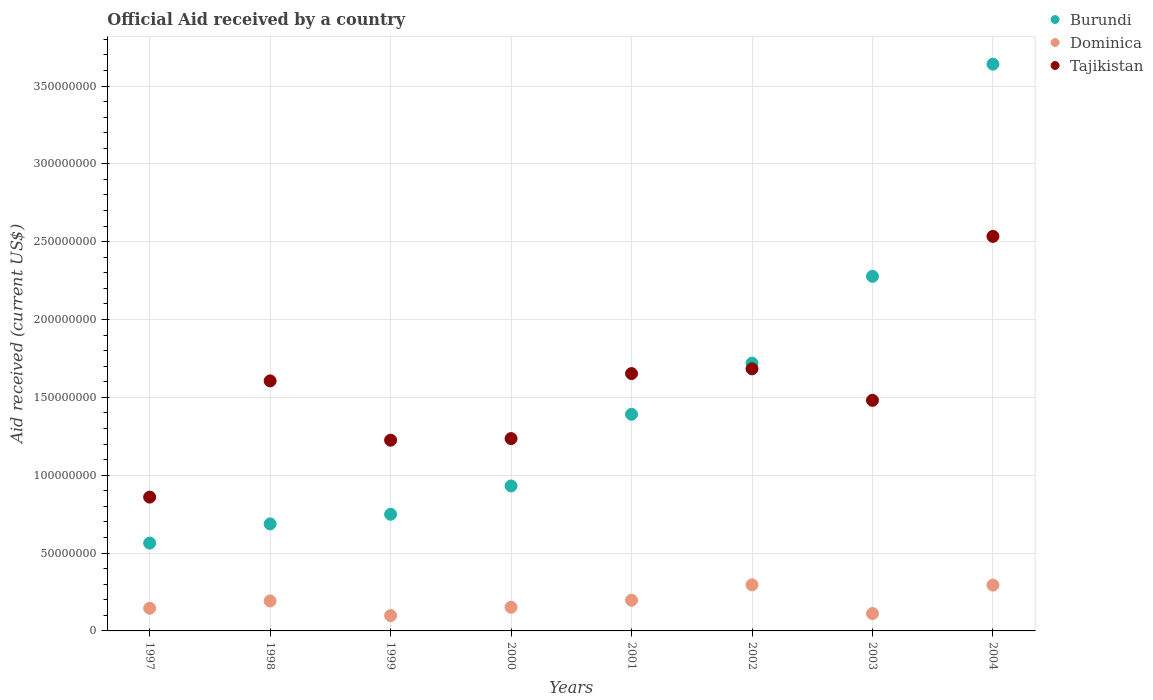What is the net official aid received in Tajikistan in 1999?
Give a very brief answer. 1.22e+08. Across all years, what is the maximum net official aid received in Burundi?
Ensure brevity in your answer.  3.64e+08. Across all years, what is the minimum net official aid received in Dominica?
Make the answer very short. 9.84e+06. In which year was the net official aid received in Tajikistan maximum?
Ensure brevity in your answer.  2004. What is the total net official aid received in Tajikistan in the graph?
Keep it short and to the point. 1.23e+09. What is the difference between the net official aid received in Burundi in 1997 and that in 1999?
Ensure brevity in your answer.  -1.85e+07. What is the difference between the net official aid received in Burundi in 2003 and the net official aid received in Tajikistan in 2000?
Provide a succinct answer. 1.04e+08. What is the average net official aid received in Dominica per year?
Keep it short and to the point. 1.86e+07. In the year 1999, what is the difference between the net official aid received in Burundi and net official aid received in Dominica?
Offer a very short reply. 6.51e+07. What is the ratio of the net official aid received in Tajikistan in 2000 to that in 2004?
Ensure brevity in your answer.  0.49. Is the net official aid received in Dominica in 2000 less than that in 2001?
Ensure brevity in your answer.  Yes. Is the difference between the net official aid received in Burundi in 1998 and 2004 greater than the difference between the net official aid received in Dominica in 1998 and 2004?
Keep it short and to the point. No. What is the difference between the highest and the second highest net official aid received in Burundi?
Offer a very short reply. 1.36e+08. What is the difference between the highest and the lowest net official aid received in Tajikistan?
Keep it short and to the point. 1.67e+08. In how many years, is the net official aid received in Tajikistan greater than the average net official aid received in Tajikistan taken over all years?
Keep it short and to the point. 4. Is it the case that in every year, the sum of the net official aid received in Dominica and net official aid received in Tajikistan  is greater than the net official aid received in Burundi?
Ensure brevity in your answer.  No. Does the net official aid received in Tajikistan monotonically increase over the years?
Provide a succinct answer. No. Is the net official aid received in Burundi strictly greater than the net official aid received in Dominica over the years?
Give a very brief answer. Yes. Does the graph contain grids?
Your response must be concise. Yes. How are the legend labels stacked?
Your answer should be very brief. Vertical. What is the title of the graph?
Offer a terse response. Official Aid received by a country. What is the label or title of the X-axis?
Your answer should be compact. Years. What is the label or title of the Y-axis?
Keep it short and to the point. Aid received (current US$). What is the Aid received (current US$) in Burundi in 1997?
Offer a terse response. 5.64e+07. What is the Aid received (current US$) of Dominica in 1997?
Ensure brevity in your answer.  1.46e+07. What is the Aid received (current US$) of Tajikistan in 1997?
Provide a succinct answer. 8.59e+07. What is the Aid received (current US$) in Burundi in 1998?
Your response must be concise. 6.88e+07. What is the Aid received (current US$) in Dominica in 1998?
Ensure brevity in your answer.  1.93e+07. What is the Aid received (current US$) in Tajikistan in 1998?
Your response must be concise. 1.61e+08. What is the Aid received (current US$) of Burundi in 1999?
Your answer should be very brief. 7.49e+07. What is the Aid received (current US$) in Dominica in 1999?
Ensure brevity in your answer.  9.84e+06. What is the Aid received (current US$) of Tajikistan in 1999?
Your answer should be very brief. 1.22e+08. What is the Aid received (current US$) of Burundi in 2000?
Offer a terse response. 9.31e+07. What is the Aid received (current US$) in Dominica in 2000?
Give a very brief answer. 1.52e+07. What is the Aid received (current US$) of Tajikistan in 2000?
Offer a terse response. 1.24e+08. What is the Aid received (current US$) in Burundi in 2001?
Your answer should be very brief. 1.39e+08. What is the Aid received (current US$) of Dominica in 2001?
Provide a succinct answer. 1.97e+07. What is the Aid received (current US$) in Tajikistan in 2001?
Provide a succinct answer. 1.65e+08. What is the Aid received (current US$) in Burundi in 2002?
Keep it short and to the point. 1.72e+08. What is the Aid received (current US$) in Dominica in 2002?
Your answer should be very brief. 2.96e+07. What is the Aid received (current US$) of Tajikistan in 2002?
Offer a terse response. 1.68e+08. What is the Aid received (current US$) in Burundi in 2003?
Your response must be concise. 2.28e+08. What is the Aid received (current US$) in Dominica in 2003?
Give a very brief answer. 1.12e+07. What is the Aid received (current US$) in Tajikistan in 2003?
Offer a very short reply. 1.48e+08. What is the Aid received (current US$) in Burundi in 2004?
Your answer should be very brief. 3.64e+08. What is the Aid received (current US$) of Dominica in 2004?
Ensure brevity in your answer.  2.94e+07. What is the Aid received (current US$) in Tajikistan in 2004?
Provide a succinct answer. 2.53e+08. Across all years, what is the maximum Aid received (current US$) in Burundi?
Keep it short and to the point. 3.64e+08. Across all years, what is the maximum Aid received (current US$) in Dominica?
Keep it short and to the point. 2.96e+07. Across all years, what is the maximum Aid received (current US$) of Tajikistan?
Provide a succinct answer. 2.53e+08. Across all years, what is the minimum Aid received (current US$) of Burundi?
Offer a very short reply. 5.64e+07. Across all years, what is the minimum Aid received (current US$) in Dominica?
Give a very brief answer. 9.84e+06. Across all years, what is the minimum Aid received (current US$) in Tajikistan?
Offer a terse response. 8.59e+07. What is the total Aid received (current US$) of Burundi in the graph?
Provide a succinct answer. 1.20e+09. What is the total Aid received (current US$) in Dominica in the graph?
Offer a terse response. 1.49e+08. What is the total Aid received (current US$) of Tajikistan in the graph?
Provide a succinct answer. 1.23e+09. What is the difference between the Aid received (current US$) in Burundi in 1997 and that in 1998?
Your answer should be very brief. -1.24e+07. What is the difference between the Aid received (current US$) of Dominica in 1997 and that in 1998?
Make the answer very short. -4.70e+06. What is the difference between the Aid received (current US$) of Tajikistan in 1997 and that in 1998?
Give a very brief answer. -7.46e+07. What is the difference between the Aid received (current US$) in Burundi in 1997 and that in 1999?
Make the answer very short. -1.85e+07. What is the difference between the Aid received (current US$) of Dominica in 1997 and that in 1999?
Offer a very short reply. 4.72e+06. What is the difference between the Aid received (current US$) of Tajikistan in 1997 and that in 1999?
Offer a terse response. -3.66e+07. What is the difference between the Aid received (current US$) in Burundi in 1997 and that in 2000?
Your answer should be compact. -3.67e+07. What is the difference between the Aid received (current US$) in Dominica in 1997 and that in 2000?
Offer a terse response. -6.30e+05. What is the difference between the Aid received (current US$) in Tajikistan in 1997 and that in 2000?
Your answer should be compact. -3.76e+07. What is the difference between the Aid received (current US$) in Burundi in 1997 and that in 2001?
Ensure brevity in your answer.  -8.27e+07. What is the difference between the Aid received (current US$) in Dominica in 1997 and that in 2001?
Ensure brevity in your answer.  -5.13e+06. What is the difference between the Aid received (current US$) in Tajikistan in 1997 and that in 2001?
Your answer should be very brief. -7.94e+07. What is the difference between the Aid received (current US$) of Burundi in 1997 and that in 2002?
Provide a succinct answer. -1.16e+08. What is the difference between the Aid received (current US$) of Dominica in 1997 and that in 2002?
Provide a short and direct response. -1.50e+07. What is the difference between the Aid received (current US$) in Tajikistan in 1997 and that in 2002?
Make the answer very short. -8.24e+07. What is the difference between the Aid received (current US$) in Burundi in 1997 and that in 2003?
Offer a terse response. -1.71e+08. What is the difference between the Aid received (current US$) in Dominica in 1997 and that in 2003?
Provide a short and direct response. 3.39e+06. What is the difference between the Aid received (current US$) in Tajikistan in 1997 and that in 2003?
Your answer should be very brief. -6.22e+07. What is the difference between the Aid received (current US$) in Burundi in 1997 and that in 2004?
Keep it short and to the point. -3.08e+08. What is the difference between the Aid received (current US$) of Dominica in 1997 and that in 2004?
Provide a succinct answer. -1.49e+07. What is the difference between the Aid received (current US$) in Tajikistan in 1997 and that in 2004?
Provide a succinct answer. -1.67e+08. What is the difference between the Aid received (current US$) of Burundi in 1998 and that in 1999?
Offer a terse response. -6.17e+06. What is the difference between the Aid received (current US$) in Dominica in 1998 and that in 1999?
Your answer should be very brief. 9.42e+06. What is the difference between the Aid received (current US$) in Tajikistan in 1998 and that in 1999?
Ensure brevity in your answer.  3.81e+07. What is the difference between the Aid received (current US$) of Burundi in 1998 and that in 2000?
Ensure brevity in your answer.  -2.44e+07. What is the difference between the Aid received (current US$) in Dominica in 1998 and that in 2000?
Make the answer very short. 4.07e+06. What is the difference between the Aid received (current US$) in Tajikistan in 1998 and that in 2000?
Make the answer very short. 3.70e+07. What is the difference between the Aid received (current US$) of Burundi in 1998 and that in 2001?
Your answer should be compact. -7.04e+07. What is the difference between the Aid received (current US$) in Dominica in 1998 and that in 2001?
Give a very brief answer. -4.30e+05. What is the difference between the Aid received (current US$) in Tajikistan in 1998 and that in 2001?
Provide a short and direct response. -4.71e+06. What is the difference between the Aid received (current US$) in Burundi in 1998 and that in 2002?
Provide a short and direct response. -1.03e+08. What is the difference between the Aid received (current US$) in Dominica in 1998 and that in 2002?
Your response must be concise. -1.03e+07. What is the difference between the Aid received (current US$) in Tajikistan in 1998 and that in 2002?
Make the answer very short. -7.76e+06. What is the difference between the Aid received (current US$) in Burundi in 1998 and that in 2003?
Provide a short and direct response. -1.59e+08. What is the difference between the Aid received (current US$) of Dominica in 1998 and that in 2003?
Give a very brief answer. 8.09e+06. What is the difference between the Aid received (current US$) in Tajikistan in 1998 and that in 2003?
Your answer should be compact. 1.25e+07. What is the difference between the Aid received (current US$) of Burundi in 1998 and that in 2004?
Offer a very short reply. -2.95e+08. What is the difference between the Aid received (current US$) in Dominica in 1998 and that in 2004?
Make the answer very short. -1.02e+07. What is the difference between the Aid received (current US$) in Tajikistan in 1998 and that in 2004?
Offer a very short reply. -9.28e+07. What is the difference between the Aid received (current US$) of Burundi in 1999 and that in 2000?
Ensure brevity in your answer.  -1.82e+07. What is the difference between the Aid received (current US$) in Dominica in 1999 and that in 2000?
Offer a terse response. -5.35e+06. What is the difference between the Aid received (current US$) of Tajikistan in 1999 and that in 2000?
Your response must be concise. -1.04e+06. What is the difference between the Aid received (current US$) of Burundi in 1999 and that in 2001?
Offer a very short reply. -6.42e+07. What is the difference between the Aid received (current US$) of Dominica in 1999 and that in 2001?
Your answer should be compact. -9.85e+06. What is the difference between the Aid received (current US$) in Tajikistan in 1999 and that in 2001?
Your answer should be very brief. -4.28e+07. What is the difference between the Aid received (current US$) of Burundi in 1999 and that in 2002?
Ensure brevity in your answer.  -9.71e+07. What is the difference between the Aid received (current US$) in Dominica in 1999 and that in 2002?
Offer a terse response. -1.98e+07. What is the difference between the Aid received (current US$) in Tajikistan in 1999 and that in 2002?
Your answer should be very brief. -4.58e+07. What is the difference between the Aid received (current US$) of Burundi in 1999 and that in 2003?
Offer a very short reply. -1.53e+08. What is the difference between the Aid received (current US$) in Dominica in 1999 and that in 2003?
Make the answer very short. -1.33e+06. What is the difference between the Aid received (current US$) in Tajikistan in 1999 and that in 2003?
Your answer should be very brief. -2.56e+07. What is the difference between the Aid received (current US$) in Burundi in 1999 and that in 2004?
Your answer should be very brief. -2.89e+08. What is the difference between the Aid received (current US$) in Dominica in 1999 and that in 2004?
Offer a very short reply. -1.96e+07. What is the difference between the Aid received (current US$) of Tajikistan in 1999 and that in 2004?
Ensure brevity in your answer.  -1.31e+08. What is the difference between the Aid received (current US$) of Burundi in 2000 and that in 2001?
Give a very brief answer. -4.60e+07. What is the difference between the Aid received (current US$) in Dominica in 2000 and that in 2001?
Offer a terse response. -4.50e+06. What is the difference between the Aid received (current US$) of Tajikistan in 2000 and that in 2001?
Your answer should be compact. -4.18e+07. What is the difference between the Aid received (current US$) in Burundi in 2000 and that in 2002?
Your response must be concise. -7.89e+07. What is the difference between the Aid received (current US$) of Dominica in 2000 and that in 2002?
Ensure brevity in your answer.  -1.44e+07. What is the difference between the Aid received (current US$) in Tajikistan in 2000 and that in 2002?
Provide a succinct answer. -4.48e+07. What is the difference between the Aid received (current US$) in Burundi in 2000 and that in 2003?
Your response must be concise. -1.35e+08. What is the difference between the Aid received (current US$) in Dominica in 2000 and that in 2003?
Ensure brevity in your answer.  4.02e+06. What is the difference between the Aid received (current US$) in Tajikistan in 2000 and that in 2003?
Offer a terse response. -2.46e+07. What is the difference between the Aid received (current US$) in Burundi in 2000 and that in 2004?
Your answer should be compact. -2.71e+08. What is the difference between the Aid received (current US$) in Dominica in 2000 and that in 2004?
Ensure brevity in your answer.  -1.42e+07. What is the difference between the Aid received (current US$) of Tajikistan in 2000 and that in 2004?
Keep it short and to the point. -1.30e+08. What is the difference between the Aid received (current US$) in Burundi in 2001 and that in 2002?
Offer a terse response. -3.28e+07. What is the difference between the Aid received (current US$) of Dominica in 2001 and that in 2002?
Your answer should be very brief. -9.91e+06. What is the difference between the Aid received (current US$) in Tajikistan in 2001 and that in 2002?
Make the answer very short. -3.05e+06. What is the difference between the Aid received (current US$) in Burundi in 2001 and that in 2003?
Offer a terse response. -8.86e+07. What is the difference between the Aid received (current US$) in Dominica in 2001 and that in 2003?
Ensure brevity in your answer.  8.52e+06. What is the difference between the Aid received (current US$) in Tajikistan in 2001 and that in 2003?
Keep it short and to the point. 1.72e+07. What is the difference between the Aid received (current US$) of Burundi in 2001 and that in 2004?
Your answer should be compact. -2.25e+08. What is the difference between the Aid received (current US$) of Dominica in 2001 and that in 2004?
Ensure brevity in your answer.  -9.75e+06. What is the difference between the Aid received (current US$) of Tajikistan in 2001 and that in 2004?
Your response must be concise. -8.81e+07. What is the difference between the Aid received (current US$) of Burundi in 2002 and that in 2003?
Keep it short and to the point. -5.58e+07. What is the difference between the Aid received (current US$) of Dominica in 2002 and that in 2003?
Offer a very short reply. 1.84e+07. What is the difference between the Aid received (current US$) in Tajikistan in 2002 and that in 2003?
Give a very brief answer. 2.02e+07. What is the difference between the Aid received (current US$) of Burundi in 2002 and that in 2004?
Your answer should be compact. -1.92e+08. What is the difference between the Aid received (current US$) of Tajikistan in 2002 and that in 2004?
Give a very brief answer. -8.51e+07. What is the difference between the Aid received (current US$) in Burundi in 2003 and that in 2004?
Offer a terse response. -1.36e+08. What is the difference between the Aid received (current US$) of Dominica in 2003 and that in 2004?
Give a very brief answer. -1.83e+07. What is the difference between the Aid received (current US$) of Tajikistan in 2003 and that in 2004?
Ensure brevity in your answer.  -1.05e+08. What is the difference between the Aid received (current US$) of Burundi in 1997 and the Aid received (current US$) of Dominica in 1998?
Give a very brief answer. 3.71e+07. What is the difference between the Aid received (current US$) of Burundi in 1997 and the Aid received (current US$) of Tajikistan in 1998?
Give a very brief answer. -1.04e+08. What is the difference between the Aid received (current US$) of Dominica in 1997 and the Aid received (current US$) of Tajikistan in 1998?
Provide a short and direct response. -1.46e+08. What is the difference between the Aid received (current US$) of Burundi in 1997 and the Aid received (current US$) of Dominica in 1999?
Your response must be concise. 4.66e+07. What is the difference between the Aid received (current US$) of Burundi in 1997 and the Aid received (current US$) of Tajikistan in 1999?
Provide a short and direct response. -6.61e+07. What is the difference between the Aid received (current US$) of Dominica in 1997 and the Aid received (current US$) of Tajikistan in 1999?
Offer a terse response. -1.08e+08. What is the difference between the Aid received (current US$) in Burundi in 1997 and the Aid received (current US$) in Dominica in 2000?
Ensure brevity in your answer.  4.12e+07. What is the difference between the Aid received (current US$) of Burundi in 1997 and the Aid received (current US$) of Tajikistan in 2000?
Your answer should be compact. -6.71e+07. What is the difference between the Aid received (current US$) in Dominica in 1997 and the Aid received (current US$) in Tajikistan in 2000?
Provide a succinct answer. -1.09e+08. What is the difference between the Aid received (current US$) in Burundi in 1997 and the Aid received (current US$) in Dominica in 2001?
Provide a short and direct response. 3.67e+07. What is the difference between the Aid received (current US$) in Burundi in 1997 and the Aid received (current US$) in Tajikistan in 2001?
Make the answer very short. -1.09e+08. What is the difference between the Aid received (current US$) in Dominica in 1997 and the Aid received (current US$) in Tajikistan in 2001?
Your answer should be very brief. -1.51e+08. What is the difference between the Aid received (current US$) in Burundi in 1997 and the Aid received (current US$) in Dominica in 2002?
Make the answer very short. 2.68e+07. What is the difference between the Aid received (current US$) of Burundi in 1997 and the Aid received (current US$) of Tajikistan in 2002?
Keep it short and to the point. -1.12e+08. What is the difference between the Aid received (current US$) of Dominica in 1997 and the Aid received (current US$) of Tajikistan in 2002?
Your answer should be very brief. -1.54e+08. What is the difference between the Aid received (current US$) of Burundi in 1997 and the Aid received (current US$) of Dominica in 2003?
Ensure brevity in your answer.  4.52e+07. What is the difference between the Aid received (current US$) in Burundi in 1997 and the Aid received (current US$) in Tajikistan in 2003?
Make the answer very short. -9.17e+07. What is the difference between the Aid received (current US$) in Dominica in 1997 and the Aid received (current US$) in Tajikistan in 2003?
Your answer should be compact. -1.34e+08. What is the difference between the Aid received (current US$) in Burundi in 1997 and the Aid received (current US$) in Dominica in 2004?
Provide a succinct answer. 2.70e+07. What is the difference between the Aid received (current US$) in Burundi in 1997 and the Aid received (current US$) in Tajikistan in 2004?
Offer a very short reply. -1.97e+08. What is the difference between the Aid received (current US$) of Dominica in 1997 and the Aid received (current US$) of Tajikistan in 2004?
Offer a terse response. -2.39e+08. What is the difference between the Aid received (current US$) in Burundi in 1998 and the Aid received (current US$) in Dominica in 1999?
Ensure brevity in your answer.  5.89e+07. What is the difference between the Aid received (current US$) of Burundi in 1998 and the Aid received (current US$) of Tajikistan in 1999?
Your answer should be compact. -5.38e+07. What is the difference between the Aid received (current US$) in Dominica in 1998 and the Aid received (current US$) in Tajikistan in 1999?
Provide a short and direct response. -1.03e+08. What is the difference between the Aid received (current US$) in Burundi in 1998 and the Aid received (current US$) in Dominica in 2000?
Offer a terse response. 5.36e+07. What is the difference between the Aid received (current US$) of Burundi in 1998 and the Aid received (current US$) of Tajikistan in 2000?
Provide a succinct answer. -5.48e+07. What is the difference between the Aid received (current US$) in Dominica in 1998 and the Aid received (current US$) in Tajikistan in 2000?
Your answer should be compact. -1.04e+08. What is the difference between the Aid received (current US$) of Burundi in 1998 and the Aid received (current US$) of Dominica in 2001?
Your answer should be very brief. 4.91e+07. What is the difference between the Aid received (current US$) in Burundi in 1998 and the Aid received (current US$) in Tajikistan in 2001?
Make the answer very short. -9.66e+07. What is the difference between the Aid received (current US$) of Dominica in 1998 and the Aid received (current US$) of Tajikistan in 2001?
Offer a terse response. -1.46e+08. What is the difference between the Aid received (current US$) of Burundi in 1998 and the Aid received (current US$) of Dominica in 2002?
Give a very brief answer. 3.92e+07. What is the difference between the Aid received (current US$) of Burundi in 1998 and the Aid received (current US$) of Tajikistan in 2002?
Provide a short and direct response. -9.96e+07. What is the difference between the Aid received (current US$) of Dominica in 1998 and the Aid received (current US$) of Tajikistan in 2002?
Give a very brief answer. -1.49e+08. What is the difference between the Aid received (current US$) in Burundi in 1998 and the Aid received (current US$) in Dominica in 2003?
Offer a very short reply. 5.76e+07. What is the difference between the Aid received (current US$) in Burundi in 1998 and the Aid received (current US$) in Tajikistan in 2003?
Keep it short and to the point. -7.94e+07. What is the difference between the Aid received (current US$) in Dominica in 1998 and the Aid received (current US$) in Tajikistan in 2003?
Offer a terse response. -1.29e+08. What is the difference between the Aid received (current US$) of Burundi in 1998 and the Aid received (current US$) of Dominica in 2004?
Your response must be concise. 3.93e+07. What is the difference between the Aid received (current US$) of Burundi in 1998 and the Aid received (current US$) of Tajikistan in 2004?
Keep it short and to the point. -1.85e+08. What is the difference between the Aid received (current US$) in Dominica in 1998 and the Aid received (current US$) in Tajikistan in 2004?
Give a very brief answer. -2.34e+08. What is the difference between the Aid received (current US$) in Burundi in 1999 and the Aid received (current US$) in Dominica in 2000?
Offer a terse response. 5.97e+07. What is the difference between the Aid received (current US$) in Burundi in 1999 and the Aid received (current US$) in Tajikistan in 2000?
Provide a succinct answer. -4.86e+07. What is the difference between the Aid received (current US$) of Dominica in 1999 and the Aid received (current US$) of Tajikistan in 2000?
Your answer should be compact. -1.14e+08. What is the difference between the Aid received (current US$) of Burundi in 1999 and the Aid received (current US$) of Dominica in 2001?
Offer a terse response. 5.52e+07. What is the difference between the Aid received (current US$) of Burundi in 1999 and the Aid received (current US$) of Tajikistan in 2001?
Give a very brief answer. -9.04e+07. What is the difference between the Aid received (current US$) in Dominica in 1999 and the Aid received (current US$) in Tajikistan in 2001?
Ensure brevity in your answer.  -1.55e+08. What is the difference between the Aid received (current US$) of Burundi in 1999 and the Aid received (current US$) of Dominica in 2002?
Your response must be concise. 4.53e+07. What is the difference between the Aid received (current US$) in Burundi in 1999 and the Aid received (current US$) in Tajikistan in 2002?
Make the answer very short. -9.34e+07. What is the difference between the Aid received (current US$) of Dominica in 1999 and the Aid received (current US$) of Tajikistan in 2002?
Your response must be concise. -1.59e+08. What is the difference between the Aid received (current US$) of Burundi in 1999 and the Aid received (current US$) of Dominica in 2003?
Provide a succinct answer. 6.38e+07. What is the difference between the Aid received (current US$) in Burundi in 1999 and the Aid received (current US$) in Tajikistan in 2003?
Your answer should be compact. -7.32e+07. What is the difference between the Aid received (current US$) of Dominica in 1999 and the Aid received (current US$) of Tajikistan in 2003?
Your answer should be compact. -1.38e+08. What is the difference between the Aid received (current US$) of Burundi in 1999 and the Aid received (current US$) of Dominica in 2004?
Your answer should be compact. 4.55e+07. What is the difference between the Aid received (current US$) in Burundi in 1999 and the Aid received (current US$) in Tajikistan in 2004?
Ensure brevity in your answer.  -1.78e+08. What is the difference between the Aid received (current US$) of Dominica in 1999 and the Aid received (current US$) of Tajikistan in 2004?
Provide a short and direct response. -2.44e+08. What is the difference between the Aid received (current US$) in Burundi in 2000 and the Aid received (current US$) in Dominica in 2001?
Provide a short and direct response. 7.34e+07. What is the difference between the Aid received (current US$) of Burundi in 2000 and the Aid received (current US$) of Tajikistan in 2001?
Provide a short and direct response. -7.22e+07. What is the difference between the Aid received (current US$) of Dominica in 2000 and the Aid received (current US$) of Tajikistan in 2001?
Give a very brief answer. -1.50e+08. What is the difference between the Aid received (current US$) of Burundi in 2000 and the Aid received (current US$) of Dominica in 2002?
Make the answer very short. 6.35e+07. What is the difference between the Aid received (current US$) of Burundi in 2000 and the Aid received (current US$) of Tajikistan in 2002?
Give a very brief answer. -7.52e+07. What is the difference between the Aid received (current US$) of Dominica in 2000 and the Aid received (current US$) of Tajikistan in 2002?
Your answer should be very brief. -1.53e+08. What is the difference between the Aid received (current US$) in Burundi in 2000 and the Aid received (current US$) in Dominica in 2003?
Keep it short and to the point. 8.20e+07. What is the difference between the Aid received (current US$) in Burundi in 2000 and the Aid received (current US$) in Tajikistan in 2003?
Your answer should be very brief. -5.50e+07. What is the difference between the Aid received (current US$) of Dominica in 2000 and the Aid received (current US$) of Tajikistan in 2003?
Offer a terse response. -1.33e+08. What is the difference between the Aid received (current US$) in Burundi in 2000 and the Aid received (current US$) in Dominica in 2004?
Your response must be concise. 6.37e+07. What is the difference between the Aid received (current US$) of Burundi in 2000 and the Aid received (current US$) of Tajikistan in 2004?
Your answer should be compact. -1.60e+08. What is the difference between the Aid received (current US$) of Dominica in 2000 and the Aid received (current US$) of Tajikistan in 2004?
Ensure brevity in your answer.  -2.38e+08. What is the difference between the Aid received (current US$) of Burundi in 2001 and the Aid received (current US$) of Dominica in 2002?
Provide a short and direct response. 1.10e+08. What is the difference between the Aid received (current US$) in Burundi in 2001 and the Aid received (current US$) in Tajikistan in 2002?
Provide a short and direct response. -2.92e+07. What is the difference between the Aid received (current US$) of Dominica in 2001 and the Aid received (current US$) of Tajikistan in 2002?
Your answer should be very brief. -1.49e+08. What is the difference between the Aid received (current US$) in Burundi in 2001 and the Aid received (current US$) in Dominica in 2003?
Offer a very short reply. 1.28e+08. What is the difference between the Aid received (current US$) of Burundi in 2001 and the Aid received (current US$) of Tajikistan in 2003?
Keep it short and to the point. -8.97e+06. What is the difference between the Aid received (current US$) in Dominica in 2001 and the Aid received (current US$) in Tajikistan in 2003?
Keep it short and to the point. -1.28e+08. What is the difference between the Aid received (current US$) in Burundi in 2001 and the Aid received (current US$) in Dominica in 2004?
Make the answer very short. 1.10e+08. What is the difference between the Aid received (current US$) in Burundi in 2001 and the Aid received (current US$) in Tajikistan in 2004?
Ensure brevity in your answer.  -1.14e+08. What is the difference between the Aid received (current US$) in Dominica in 2001 and the Aid received (current US$) in Tajikistan in 2004?
Your answer should be compact. -2.34e+08. What is the difference between the Aid received (current US$) of Burundi in 2002 and the Aid received (current US$) of Dominica in 2003?
Offer a terse response. 1.61e+08. What is the difference between the Aid received (current US$) of Burundi in 2002 and the Aid received (current US$) of Tajikistan in 2003?
Your answer should be very brief. 2.39e+07. What is the difference between the Aid received (current US$) in Dominica in 2002 and the Aid received (current US$) in Tajikistan in 2003?
Keep it short and to the point. -1.19e+08. What is the difference between the Aid received (current US$) in Burundi in 2002 and the Aid received (current US$) in Dominica in 2004?
Your answer should be very brief. 1.43e+08. What is the difference between the Aid received (current US$) of Burundi in 2002 and the Aid received (current US$) of Tajikistan in 2004?
Your answer should be very brief. -8.14e+07. What is the difference between the Aid received (current US$) of Dominica in 2002 and the Aid received (current US$) of Tajikistan in 2004?
Your answer should be very brief. -2.24e+08. What is the difference between the Aid received (current US$) in Burundi in 2003 and the Aid received (current US$) in Dominica in 2004?
Your response must be concise. 1.98e+08. What is the difference between the Aid received (current US$) of Burundi in 2003 and the Aid received (current US$) of Tajikistan in 2004?
Your response must be concise. -2.57e+07. What is the difference between the Aid received (current US$) of Dominica in 2003 and the Aid received (current US$) of Tajikistan in 2004?
Give a very brief answer. -2.42e+08. What is the average Aid received (current US$) of Burundi per year?
Your answer should be compact. 1.50e+08. What is the average Aid received (current US$) in Dominica per year?
Provide a succinct answer. 1.86e+07. What is the average Aid received (current US$) in Tajikistan per year?
Ensure brevity in your answer.  1.53e+08. In the year 1997, what is the difference between the Aid received (current US$) of Burundi and Aid received (current US$) of Dominica?
Provide a short and direct response. 4.18e+07. In the year 1997, what is the difference between the Aid received (current US$) of Burundi and Aid received (current US$) of Tajikistan?
Offer a terse response. -2.95e+07. In the year 1997, what is the difference between the Aid received (current US$) of Dominica and Aid received (current US$) of Tajikistan?
Offer a terse response. -7.14e+07. In the year 1998, what is the difference between the Aid received (current US$) of Burundi and Aid received (current US$) of Dominica?
Offer a terse response. 4.95e+07. In the year 1998, what is the difference between the Aid received (current US$) in Burundi and Aid received (current US$) in Tajikistan?
Make the answer very short. -9.18e+07. In the year 1998, what is the difference between the Aid received (current US$) of Dominica and Aid received (current US$) of Tajikistan?
Your answer should be very brief. -1.41e+08. In the year 1999, what is the difference between the Aid received (current US$) of Burundi and Aid received (current US$) of Dominica?
Ensure brevity in your answer.  6.51e+07. In the year 1999, what is the difference between the Aid received (current US$) in Burundi and Aid received (current US$) in Tajikistan?
Offer a very short reply. -4.76e+07. In the year 1999, what is the difference between the Aid received (current US$) in Dominica and Aid received (current US$) in Tajikistan?
Keep it short and to the point. -1.13e+08. In the year 2000, what is the difference between the Aid received (current US$) in Burundi and Aid received (current US$) in Dominica?
Give a very brief answer. 7.79e+07. In the year 2000, what is the difference between the Aid received (current US$) in Burundi and Aid received (current US$) in Tajikistan?
Your response must be concise. -3.04e+07. In the year 2000, what is the difference between the Aid received (current US$) of Dominica and Aid received (current US$) of Tajikistan?
Offer a terse response. -1.08e+08. In the year 2001, what is the difference between the Aid received (current US$) of Burundi and Aid received (current US$) of Dominica?
Keep it short and to the point. 1.19e+08. In the year 2001, what is the difference between the Aid received (current US$) in Burundi and Aid received (current US$) in Tajikistan?
Ensure brevity in your answer.  -2.62e+07. In the year 2001, what is the difference between the Aid received (current US$) in Dominica and Aid received (current US$) in Tajikistan?
Provide a succinct answer. -1.46e+08. In the year 2002, what is the difference between the Aid received (current US$) of Burundi and Aid received (current US$) of Dominica?
Your response must be concise. 1.42e+08. In the year 2002, what is the difference between the Aid received (current US$) of Burundi and Aid received (current US$) of Tajikistan?
Give a very brief answer. 3.64e+06. In the year 2002, what is the difference between the Aid received (current US$) of Dominica and Aid received (current US$) of Tajikistan?
Offer a terse response. -1.39e+08. In the year 2003, what is the difference between the Aid received (current US$) in Burundi and Aid received (current US$) in Dominica?
Your answer should be very brief. 2.17e+08. In the year 2003, what is the difference between the Aid received (current US$) of Burundi and Aid received (current US$) of Tajikistan?
Keep it short and to the point. 7.96e+07. In the year 2003, what is the difference between the Aid received (current US$) of Dominica and Aid received (current US$) of Tajikistan?
Make the answer very short. -1.37e+08. In the year 2004, what is the difference between the Aid received (current US$) in Burundi and Aid received (current US$) in Dominica?
Your response must be concise. 3.35e+08. In the year 2004, what is the difference between the Aid received (current US$) of Burundi and Aid received (current US$) of Tajikistan?
Offer a terse response. 1.11e+08. In the year 2004, what is the difference between the Aid received (current US$) in Dominica and Aid received (current US$) in Tajikistan?
Make the answer very short. -2.24e+08. What is the ratio of the Aid received (current US$) of Burundi in 1997 to that in 1998?
Offer a very short reply. 0.82. What is the ratio of the Aid received (current US$) of Dominica in 1997 to that in 1998?
Make the answer very short. 0.76. What is the ratio of the Aid received (current US$) in Tajikistan in 1997 to that in 1998?
Your answer should be compact. 0.54. What is the ratio of the Aid received (current US$) in Burundi in 1997 to that in 1999?
Offer a terse response. 0.75. What is the ratio of the Aid received (current US$) of Dominica in 1997 to that in 1999?
Your answer should be compact. 1.48. What is the ratio of the Aid received (current US$) of Tajikistan in 1997 to that in 1999?
Your answer should be very brief. 0.7. What is the ratio of the Aid received (current US$) in Burundi in 1997 to that in 2000?
Your answer should be very brief. 0.61. What is the ratio of the Aid received (current US$) of Dominica in 1997 to that in 2000?
Keep it short and to the point. 0.96. What is the ratio of the Aid received (current US$) of Tajikistan in 1997 to that in 2000?
Your answer should be compact. 0.7. What is the ratio of the Aid received (current US$) of Burundi in 1997 to that in 2001?
Keep it short and to the point. 0.41. What is the ratio of the Aid received (current US$) in Dominica in 1997 to that in 2001?
Your answer should be compact. 0.74. What is the ratio of the Aid received (current US$) in Tajikistan in 1997 to that in 2001?
Make the answer very short. 0.52. What is the ratio of the Aid received (current US$) of Burundi in 1997 to that in 2002?
Keep it short and to the point. 0.33. What is the ratio of the Aid received (current US$) of Dominica in 1997 to that in 2002?
Your answer should be compact. 0.49. What is the ratio of the Aid received (current US$) of Tajikistan in 1997 to that in 2002?
Make the answer very short. 0.51. What is the ratio of the Aid received (current US$) of Burundi in 1997 to that in 2003?
Your response must be concise. 0.25. What is the ratio of the Aid received (current US$) in Dominica in 1997 to that in 2003?
Provide a short and direct response. 1.3. What is the ratio of the Aid received (current US$) in Tajikistan in 1997 to that in 2003?
Provide a succinct answer. 0.58. What is the ratio of the Aid received (current US$) in Burundi in 1997 to that in 2004?
Ensure brevity in your answer.  0.15. What is the ratio of the Aid received (current US$) in Dominica in 1997 to that in 2004?
Give a very brief answer. 0.49. What is the ratio of the Aid received (current US$) in Tajikistan in 1997 to that in 2004?
Give a very brief answer. 0.34. What is the ratio of the Aid received (current US$) of Burundi in 1998 to that in 1999?
Ensure brevity in your answer.  0.92. What is the ratio of the Aid received (current US$) of Dominica in 1998 to that in 1999?
Offer a terse response. 1.96. What is the ratio of the Aid received (current US$) in Tajikistan in 1998 to that in 1999?
Ensure brevity in your answer.  1.31. What is the ratio of the Aid received (current US$) of Burundi in 1998 to that in 2000?
Make the answer very short. 0.74. What is the ratio of the Aid received (current US$) in Dominica in 1998 to that in 2000?
Provide a short and direct response. 1.27. What is the ratio of the Aid received (current US$) in Tajikistan in 1998 to that in 2000?
Offer a terse response. 1.3. What is the ratio of the Aid received (current US$) of Burundi in 1998 to that in 2001?
Keep it short and to the point. 0.49. What is the ratio of the Aid received (current US$) in Dominica in 1998 to that in 2001?
Provide a short and direct response. 0.98. What is the ratio of the Aid received (current US$) of Tajikistan in 1998 to that in 2001?
Your response must be concise. 0.97. What is the ratio of the Aid received (current US$) in Burundi in 1998 to that in 2002?
Ensure brevity in your answer.  0.4. What is the ratio of the Aid received (current US$) in Dominica in 1998 to that in 2002?
Your answer should be very brief. 0.65. What is the ratio of the Aid received (current US$) in Tajikistan in 1998 to that in 2002?
Your answer should be compact. 0.95. What is the ratio of the Aid received (current US$) of Burundi in 1998 to that in 2003?
Offer a very short reply. 0.3. What is the ratio of the Aid received (current US$) in Dominica in 1998 to that in 2003?
Make the answer very short. 1.72. What is the ratio of the Aid received (current US$) of Tajikistan in 1998 to that in 2003?
Ensure brevity in your answer.  1.08. What is the ratio of the Aid received (current US$) in Burundi in 1998 to that in 2004?
Provide a short and direct response. 0.19. What is the ratio of the Aid received (current US$) of Dominica in 1998 to that in 2004?
Provide a succinct answer. 0.65. What is the ratio of the Aid received (current US$) in Tajikistan in 1998 to that in 2004?
Offer a very short reply. 0.63. What is the ratio of the Aid received (current US$) of Burundi in 1999 to that in 2000?
Provide a succinct answer. 0.8. What is the ratio of the Aid received (current US$) of Dominica in 1999 to that in 2000?
Make the answer very short. 0.65. What is the ratio of the Aid received (current US$) of Burundi in 1999 to that in 2001?
Offer a very short reply. 0.54. What is the ratio of the Aid received (current US$) of Dominica in 1999 to that in 2001?
Your answer should be very brief. 0.5. What is the ratio of the Aid received (current US$) in Tajikistan in 1999 to that in 2001?
Keep it short and to the point. 0.74. What is the ratio of the Aid received (current US$) in Burundi in 1999 to that in 2002?
Your response must be concise. 0.44. What is the ratio of the Aid received (current US$) of Dominica in 1999 to that in 2002?
Keep it short and to the point. 0.33. What is the ratio of the Aid received (current US$) of Tajikistan in 1999 to that in 2002?
Give a very brief answer. 0.73. What is the ratio of the Aid received (current US$) of Burundi in 1999 to that in 2003?
Your answer should be compact. 0.33. What is the ratio of the Aid received (current US$) of Dominica in 1999 to that in 2003?
Offer a very short reply. 0.88. What is the ratio of the Aid received (current US$) of Tajikistan in 1999 to that in 2003?
Offer a very short reply. 0.83. What is the ratio of the Aid received (current US$) of Burundi in 1999 to that in 2004?
Keep it short and to the point. 0.21. What is the ratio of the Aid received (current US$) of Dominica in 1999 to that in 2004?
Ensure brevity in your answer.  0.33. What is the ratio of the Aid received (current US$) of Tajikistan in 1999 to that in 2004?
Provide a short and direct response. 0.48. What is the ratio of the Aid received (current US$) in Burundi in 2000 to that in 2001?
Provide a succinct answer. 0.67. What is the ratio of the Aid received (current US$) in Dominica in 2000 to that in 2001?
Give a very brief answer. 0.77. What is the ratio of the Aid received (current US$) of Tajikistan in 2000 to that in 2001?
Provide a short and direct response. 0.75. What is the ratio of the Aid received (current US$) in Burundi in 2000 to that in 2002?
Ensure brevity in your answer.  0.54. What is the ratio of the Aid received (current US$) of Dominica in 2000 to that in 2002?
Provide a short and direct response. 0.51. What is the ratio of the Aid received (current US$) of Tajikistan in 2000 to that in 2002?
Offer a terse response. 0.73. What is the ratio of the Aid received (current US$) of Burundi in 2000 to that in 2003?
Keep it short and to the point. 0.41. What is the ratio of the Aid received (current US$) of Dominica in 2000 to that in 2003?
Your answer should be very brief. 1.36. What is the ratio of the Aid received (current US$) in Tajikistan in 2000 to that in 2003?
Make the answer very short. 0.83. What is the ratio of the Aid received (current US$) of Burundi in 2000 to that in 2004?
Offer a terse response. 0.26. What is the ratio of the Aid received (current US$) of Dominica in 2000 to that in 2004?
Your answer should be compact. 0.52. What is the ratio of the Aid received (current US$) in Tajikistan in 2000 to that in 2004?
Offer a terse response. 0.49. What is the ratio of the Aid received (current US$) in Burundi in 2001 to that in 2002?
Offer a very short reply. 0.81. What is the ratio of the Aid received (current US$) of Dominica in 2001 to that in 2002?
Your response must be concise. 0.67. What is the ratio of the Aid received (current US$) of Tajikistan in 2001 to that in 2002?
Provide a succinct answer. 0.98. What is the ratio of the Aid received (current US$) in Burundi in 2001 to that in 2003?
Your answer should be compact. 0.61. What is the ratio of the Aid received (current US$) in Dominica in 2001 to that in 2003?
Your response must be concise. 1.76. What is the ratio of the Aid received (current US$) of Tajikistan in 2001 to that in 2003?
Your answer should be compact. 1.12. What is the ratio of the Aid received (current US$) in Burundi in 2001 to that in 2004?
Give a very brief answer. 0.38. What is the ratio of the Aid received (current US$) in Dominica in 2001 to that in 2004?
Provide a succinct answer. 0.67. What is the ratio of the Aid received (current US$) in Tajikistan in 2001 to that in 2004?
Give a very brief answer. 0.65. What is the ratio of the Aid received (current US$) in Burundi in 2002 to that in 2003?
Offer a terse response. 0.76. What is the ratio of the Aid received (current US$) in Dominica in 2002 to that in 2003?
Give a very brief answer. 2.65. What is the ratio of the Aid received (current US$) of Tajikistan in 2002 to that in 2003?
Your answer should be compact. 1.14. What is the ratio of the Aid received (current US$) in Burundi in 2002 to that in 2004?
Keep it short and to the point. 0.47. What is the ratio of the Aid received (current US$) in Dominica in 2002 to that in 2004?
Your answer should be very brief. 1.01. What is the ratio of the Aid received (current US$) of Tajikistan in 2002 to that in 2004?
Offer a very short reply. 0.66. What is the ratio of the Aid received (current US$) in Burundi in 2003 to that in 2004?
Provide a short and direct response. 0.63. What is the ratio of the Aid received (current US$) in Dominica in 2003 to that in 2004?
Make the answer very short. 0.38. What is the ratio of the Aid received (current US$) of Tajikistan in 2003 to that in 2004?
Your response must be concise. 0.58. What is the difference between the highest and the second highest Aid received (current US$) of Burundi?
Provide a succinct answer. 1.36e+08. What is the difference between the highest and the second highest Aid received (current US$) in Tajikistan?
Offer a very short reply. 8.51e+07. What is the difference between the highest and the lowest Aid received (current US$) of Burundi?
Keep it short and to the point. 3.08e+08. What is the difference between the highest and the lowest Aid received (current US$) of Dominica?
Ensure brevity in your answer.  1.98e+07. What is the difference between the highest and the lowest Aid received (current US$) in Tajikistan?
Provide a succinct answer. 1.67e+08. 